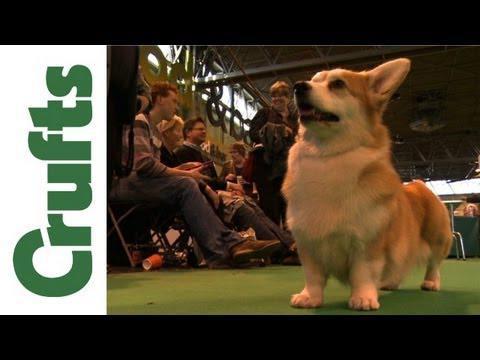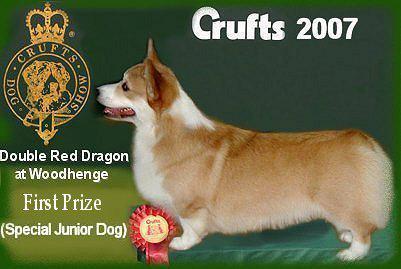The first image is the image on the left, the second image is the image on the right. For the images displayed, is the sentence "In one image, a prize ribbon is in front of a left-facing orange-and-white corgi standing on a green surface." factually correct? Answer yes or no. Yes. 